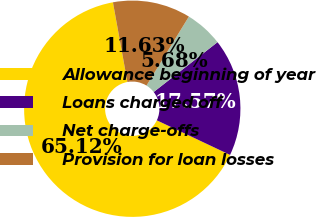Convert chart to OTSL. <chart><loc_0><loc_0><loc_500><loc_500><pie_chart><fcel>Allowance beginning of year<fcel>Loans charged off<fcel>Net charge-offs<fcel>Provision for loan losses<nl><fcel>65.12%<fcel>17.57%<fcel>5.68%<fcel>11.63%<nl></chart> 